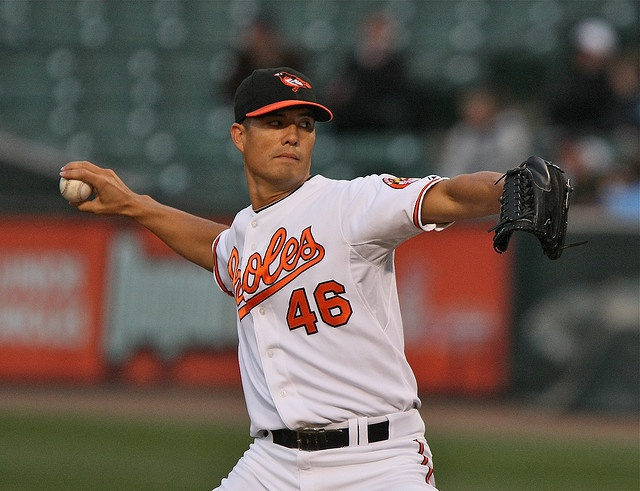Describe the objects in this image and their specific colors. I can see people in teal, lightgray, black, darkgray, and brown tones, baseball glove in teal, black, gray, and darkgray tones, and sports ball in teal, tan, gray, and maroon tones in this image. 